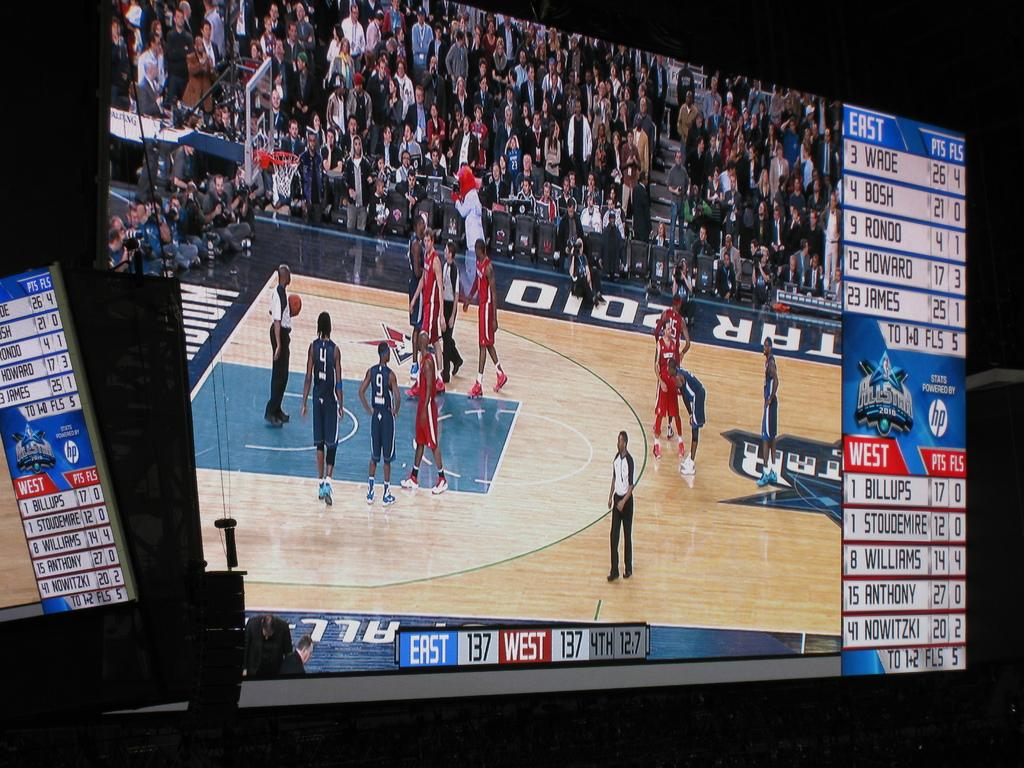<image>
Describe the image concisely. a basketball game with the game tied at 137 points each 